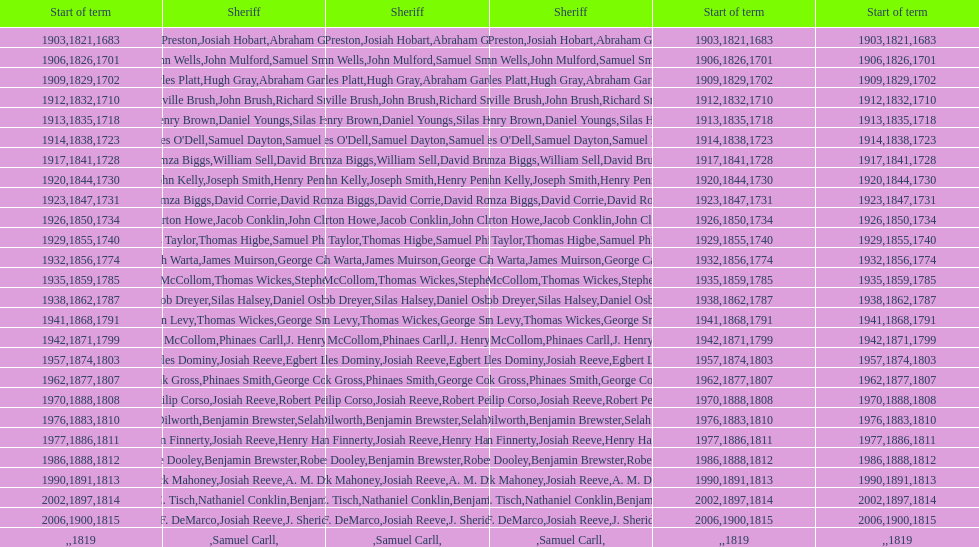How sheriffs has suffolk county had in total? 76. 